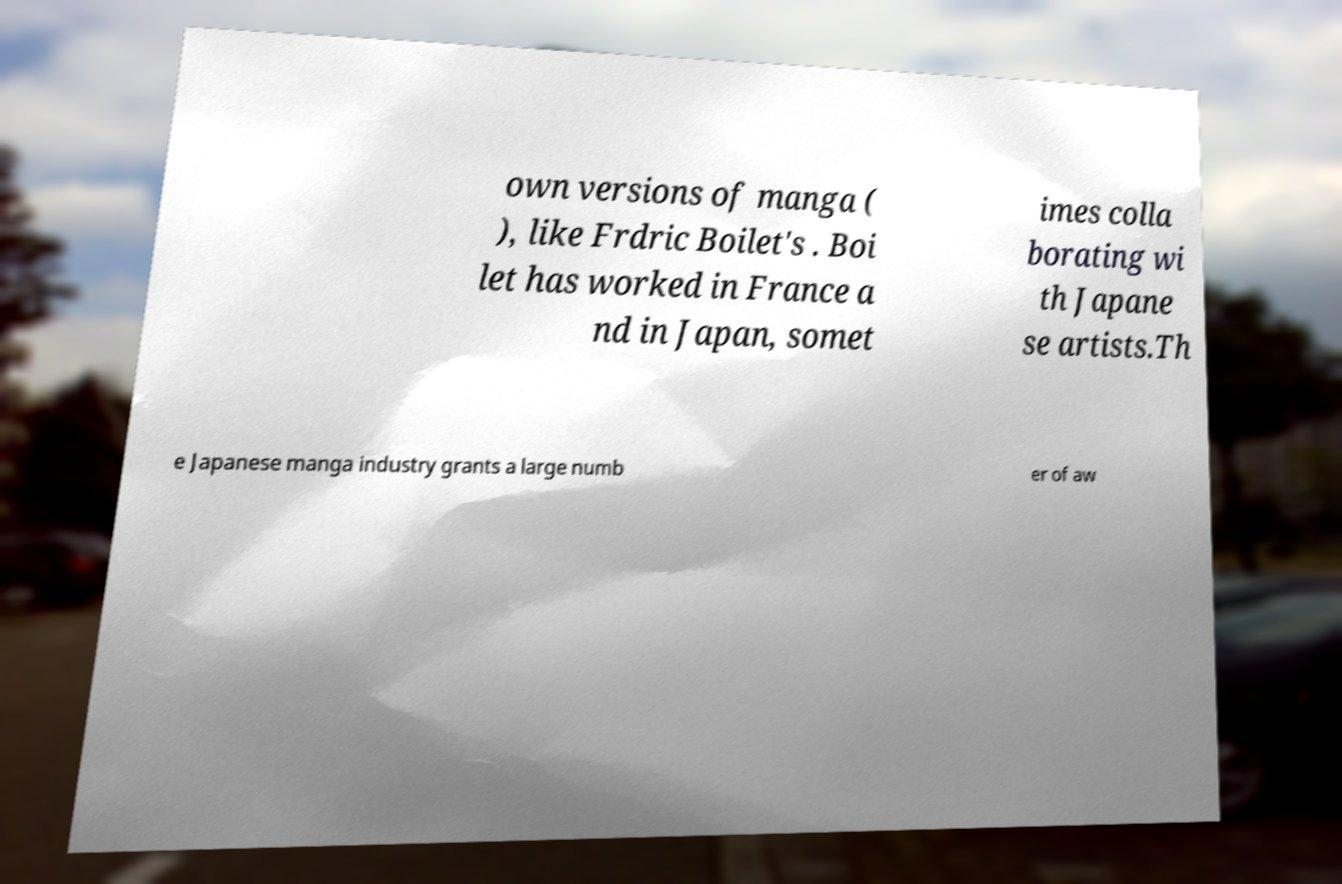There's text embedded in this image that I need extracted. Can you transcribe it verbatim? own versions of manga ( ), like Frdric Boilet's . Boi let has worked in France a nd in Japan, somet imes colla borating wi th Japane se artists.Th e Japanese manga industry grants a large numb er of aw 